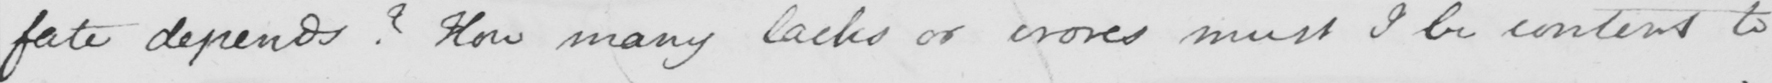Please provide the text content of this handwritten line. fate depends ?  How many lacks or  <gap/>  must I be content to 